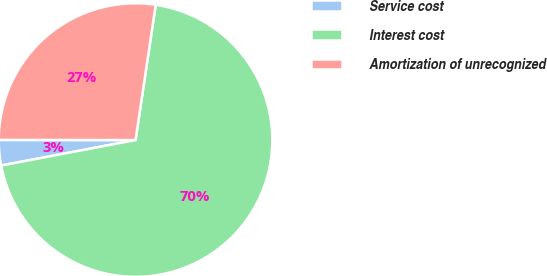Convert chart to OTSL. <chart><loc_0><loc_0><loc_500><loc_500><pie_chart><fcel>Service cost<fcel>Interest cost<fcel>Amortization of unrecognized<nl><fcel>3.0%<fcel>69.66%<fcel>27.34%<nl></chart> 